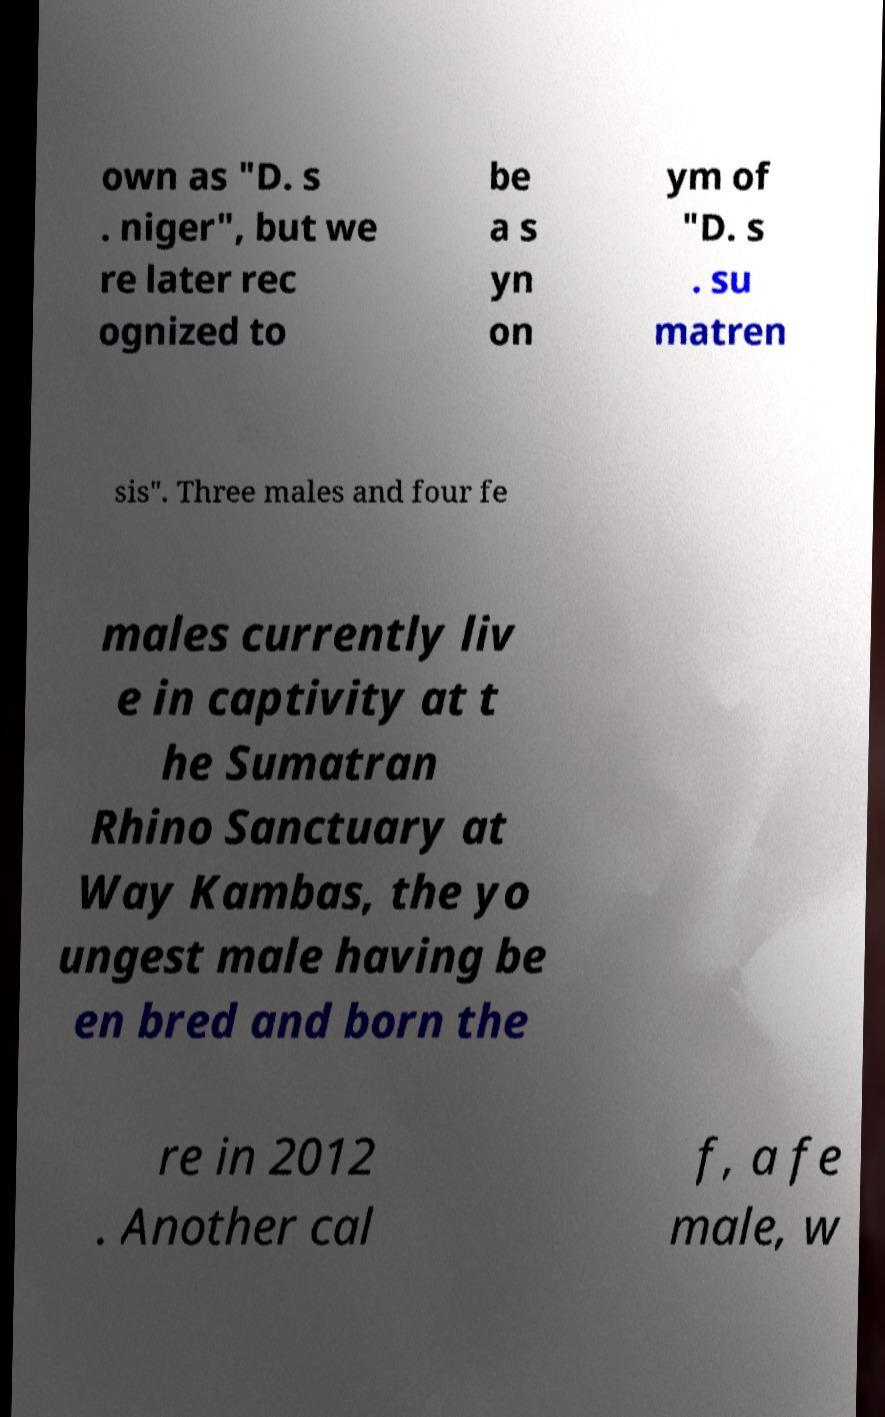What messages or text are displayed in this image? I need them in a readable, typed format. own as "D. s . niger", but we re later rec ognized to be a s yn on ym of "D. s . su matren sis". Three males and four fe males currently liv e in captivity at t he Sumatran Rhino Sanctuary at Way Kambas, the yo ungest male having be en bred and born the re in 2012 . Another cal f, a fe male, w 